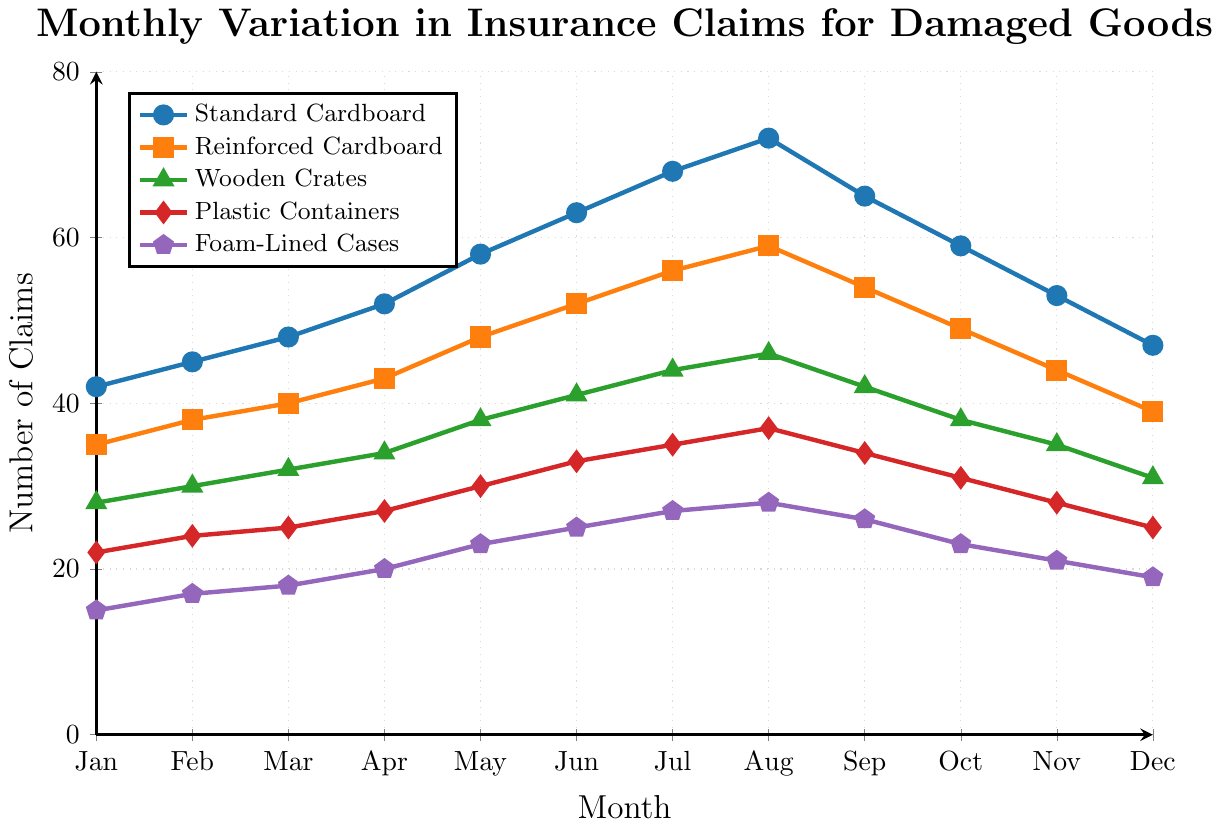What is the peak month for insurance claims for Standard Cardboard? To find the peak month, observe the highest point along the line for Standard Cardboard. This occurs in August with 72 claims.
Answer: August Which packaging type had the least number of claims in March? Look at the claims for all packaging types in March. Standard Cardboard had 48, Reinforced Cardboard had 40, Wooden Crates had 32, Plastic Containers had 25, and Foam-Lined Cases had 18. The lowest number is for Foam-Lined Cases.
Answer: Foam-Lined Cases By how much did insurance claims for Standard Cardboard increase from January to July? Subtract the number of claims in January (42) from the number in July (68). (68 - 42 = 26)
Answer: 26 What is the average number of claims for Plastic Containers from January to December? Sum the claims for each month for Plastic Containers (22 + 24 + 25 + 27 + 30 + 33 + 35 + 37 + 34 + 31 + 28 + 25 = 351) and divide by 12 (months). The average is 351 / 12 = 29.25.
Answer: 29.25 How does the number of claims for Reinforced Cardboard in November compare to that in May? Reinforced Cardboard had 44 claims in November and 48 in May. Subtracting 44 from 48 (48 - 44 = 4) shows it is 4 claims fewer in November.
Answer: 4 claims fewer Which packaging type shows the most significant drop in claims from August to December? Calculate the difference in claims from August to December for each packaging type: 
Standard Cardboard: 72 - 47 = 25
Reinforced Cardboard: 59 - 39 = 20
Wooden Crates: 46 - 31 = 15
Plastic Containers: 37 - 25 = 12
Foam-Lined Cases: 28 - 19 = 9
The largest drop is for Standard Cardboard.
Answer: Standard Cardboard What is the median number of claims for Wooden Crates over the year? List the values for Wooden Crates (28, 30, 32, 34, 38, 41, 44, 46, 42, 38, 35, 31). Arrange them in order (28, 30, 31, 32, 34, 35, 38, 38, 41, 42, 44, 46). The median is the average of the 6th and 7th values, which are 35 and 38, so (35 + 38) / 2 = 36.5.
Answer: 36.5 Between which two consecutive months does the number of claims for Foam-Lined Cases show the most significant increase? Calculate the increase between each pair of consecutive months for Foam-Lined Cases:
Jan-Feb: 17 - 15 = 2
Feb-Mar: 18 - 17 = 1
Mar-Apr: 20 - 18 = 2
Apr-May: 23 - 20 = 3
May-Jun: 25 - 23 = 2
Jun-Jul: 27 - 25 = 2
Jul-Aug: 28 - 27 = 1
Aug-Sep: 26 - 28 = -2
Sep-Oct: 23 - 26 = -3
Oct-Nov: 21 - 23 = -2
Nov-Dec: 19 - 21 = -2
The highest increase is between April and May.
Answer: April-May 